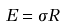Convert formula to latex. <formula><loc_0><loc_0><loc_500><loc_500>E = \sigma R</formula> 